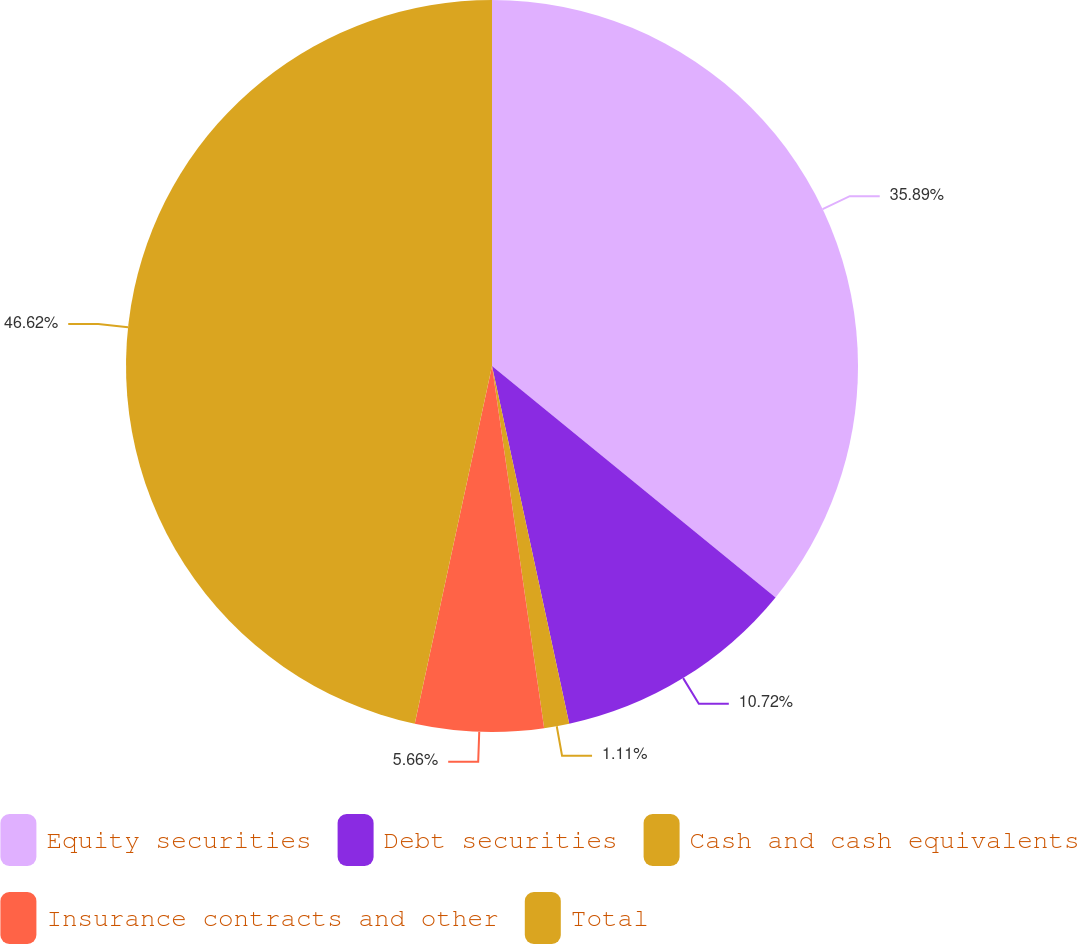Convert chart. <chart><loc_0><loc_0><loc_500><loc_500><pie_chart><fcel>Equity securities<fcel>Debt securities<fcel>Cash and cash equivalents<fcel>Insurance contracts and other<fcel>Total<nl><fcel>35.89%<fcel>10.72%<fcel>1.11%<fcel>5.66%<fcel>46.61%<nl></chart> 